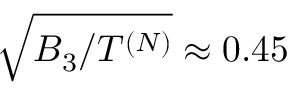Convert formula to latex. <formula><loc_0><loc_0><loc_500><loc_500>\sqrt { B _ { 3 } / T ^ { ( N ) } } \approx 0 . 4 5</formula> 